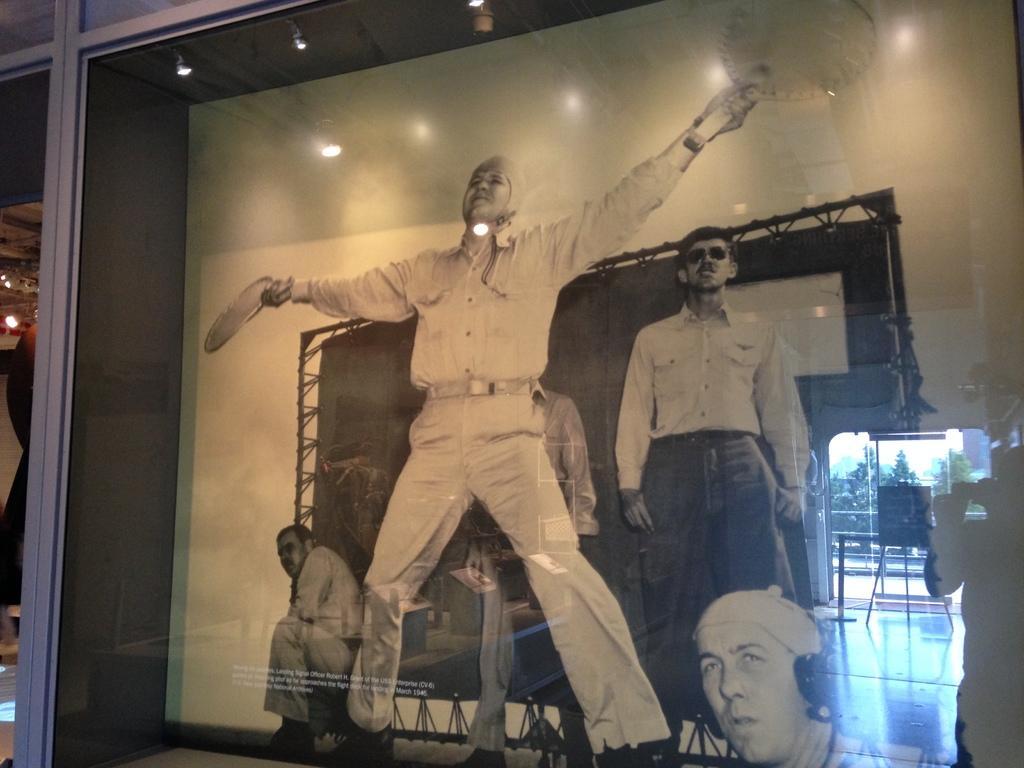Could you give a brief overview of what you see in this image? In the picture we can see a poster on it, we can see an image of a man standing and raising his hands and beside him we can see another man standing and around the poster we can see a black color frame with lights. 